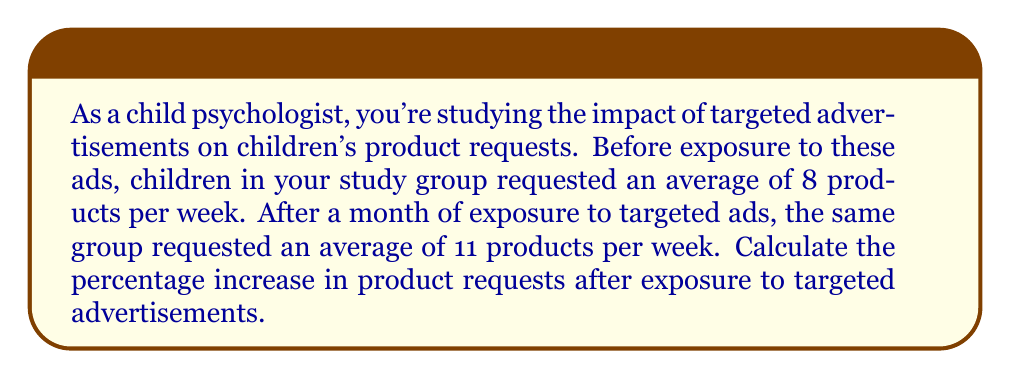Teach me how to tackle this problem. To calculate the percentage increase, we need to follow these steps:

1. Calculate the absolute increase in product requests:
   $\text{Increase} = \text{New value} - \text{Original value}$
   $\text{Increase} = 11 - 8 = 3$ products

2. Calculate the percentage increase using the formula:
   $$\text{Percentage increase} = \frac{\text{Increase}}{\text{Original value}} \times 100\%$$

3. Substitute the values into the formula:
   $$\text{Percentage increase} = \frac{3}{8} \times 100\%$$

4. Perform the division:
   $$\text{Percentage increase} = 0.375 \times 100\%$$

5. Convert the decimal to a percentage:
   $$\text{Percentage increase} = 37.5\%$$

This result indicates that exposure to targeted advertisements led to a 37.5% increase in product requests among the children in the study group.
Answer: The percentage increase in product requests after exposure to targeted advertisements is 37.5%. 